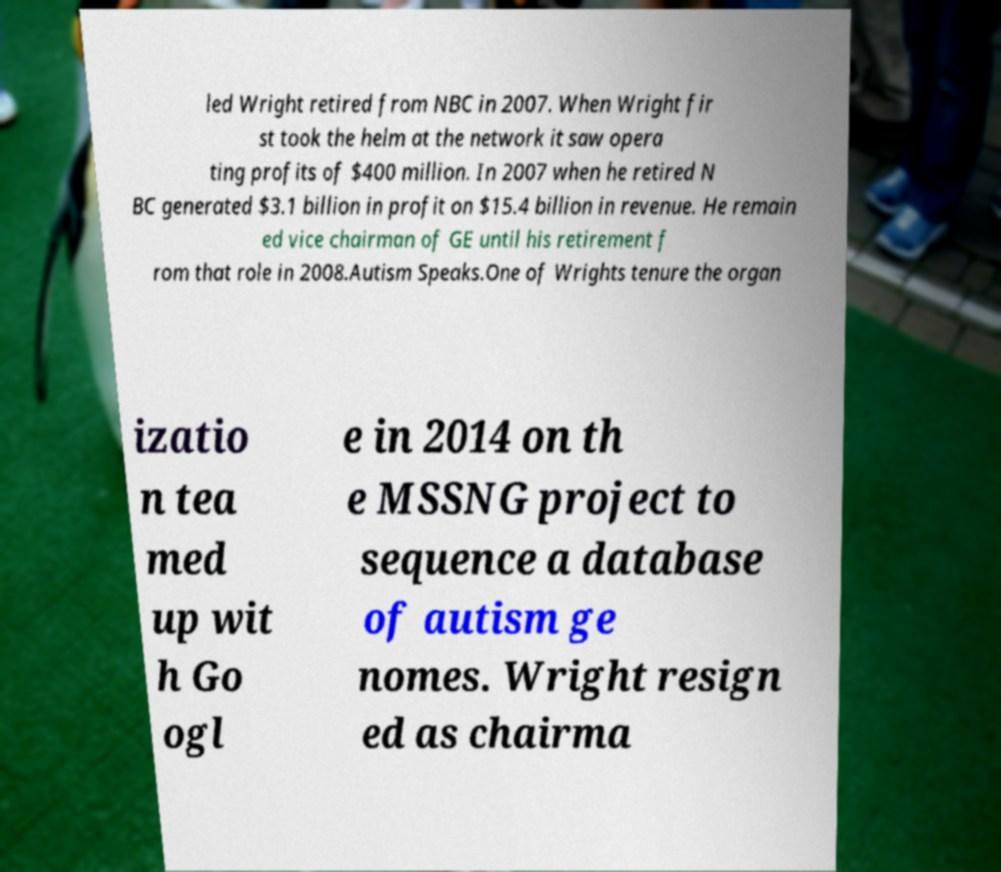Could you extract and type out the text from this image? led Wright retired from NBC in 2007. When Wright fir st took the helm at the network it saw opera ting profits of $400 million. In 2007 when he retired N BC generated $3.1 billion in profit on $15.4 billion in revenue. He remain ed vice chairman of GE until his retirement f rom that role in 2008.Autism Speaks.One of Wrights tenure the organ izatio n tea med up wit h Go ogl e in 2014 on th e MSSNG project to sequence a database of autism ge nomes. Wright resign ed as chairma 